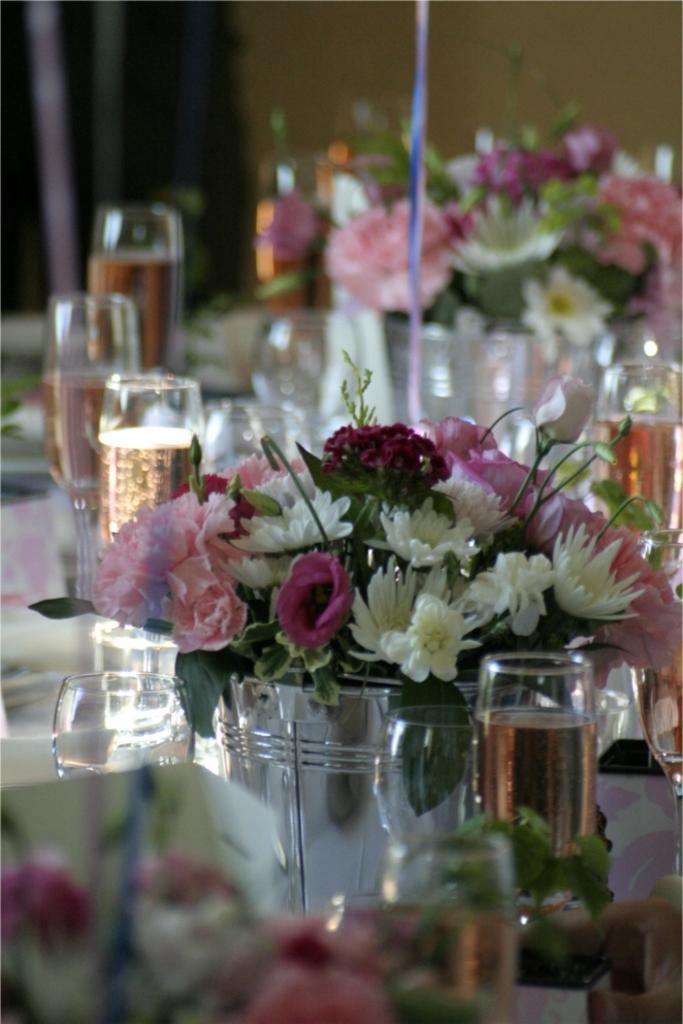What is in the glasses that are visible in the image? There are glasses filled with water in the image. What other items can be seen on the table in the image? There are flower bouquets on the table in the image. What is the primary location of both the glasses and flower bouquets in the image? Both the glasses and flower bouquets are on a table in the image. How many clams are present in the image? There are no clams present in the image. What stage of development are the flowers in the bouquets? The stage of development of the flowers cannot be determined from the image alone. 